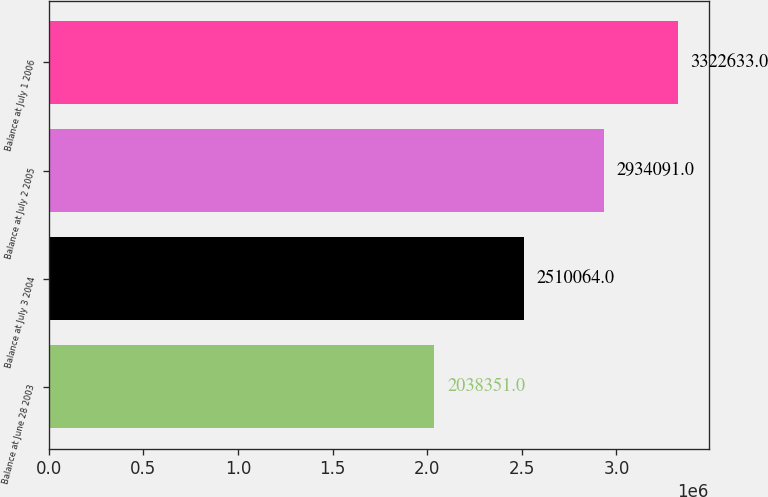Convert chart. <chart><loc_0><loc_0><loc_500><loc_500><bar_chart><fcel>Balance at June 28 2003<fcel>Balance at July 3 2004<fcel>Balance at July 2 2005<fcel>Balance at July 1 2006<nl><fcel>2.03835e+06<fcel>2.51006e+06<fcel>2.93409e+06<fcel>3.32263e+06<nl></chart> 